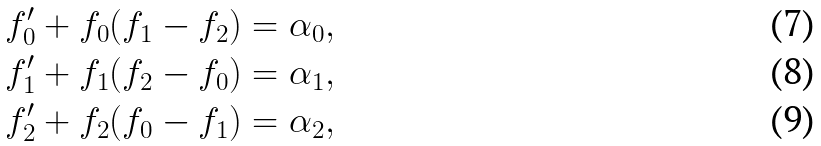<formula> <loc_0><loc_0><loc_500><loc_500>& f ^ { \prime } _ { 0 } + f _ { 0 } ( f _ { 1 } - f _ { 2 } ) = \alpha _ { 0 } , \\ & f ^ { \prime } _ { 1 } + f _ { 1 } ( f _ { 2 } - f _ { 0 } ) = \alpha _ { 1 } , \\ & f ^ { \prime } _ { 2 } + f _ { 2 } ( f _ { 0 } - f _ { 1 } ) = \alpha _ { 2 } ,</formula> 